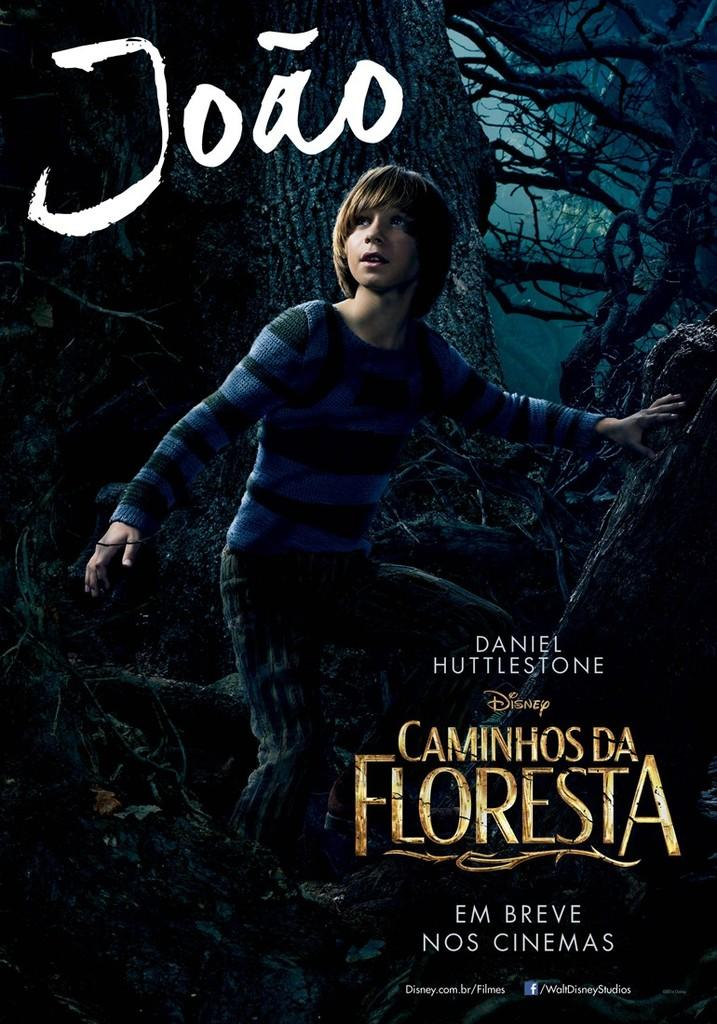<image>
Present a compact description of the photo's key features. Daniel Huttlestone stars in Disneys Caminhosda Floresta in the cinemas. 